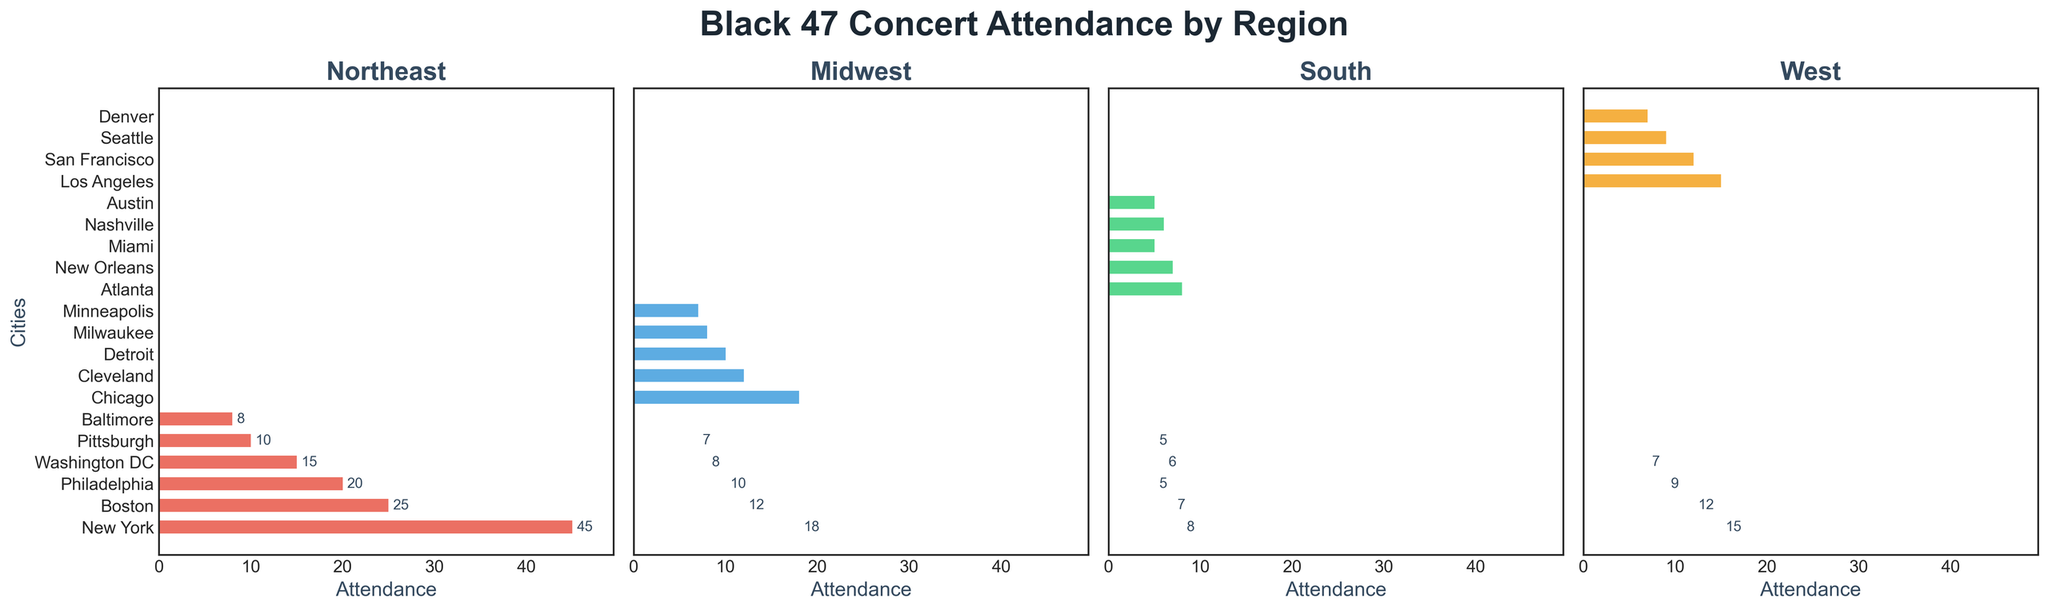How many cities in the Northeast region have concert attendance greater than 20? From the bar chart for the Northeast, count the cities with attendance bars exceeding the 20 mark, which are New York (45), Boston (25), and Philadelphia (20 but not exceeding 20). Only New York and Boston have attendance greater than 20.
Answer: 2 Which city in the Midwest has the highest concert attendance? In the Midwest subplot, the city with the highest bar is Chicago with an attendance of 18.
Answer: Chicago What is the total concert attendance for cities in the South region? Sum up the attendance values from the bars in the South subplot: Atlanta (8) + New Orleans (7) + Miami (5) + Nashville (6) + Austin (5) = 31
Answer: 31 Compare concert attendance between Los Angeles and Seattle in the West region. Which one had more attendees? In the West subplot, observe the lengths of the bars for Los Angeles and Seattle. Los Angeles has a bar at 15, while Seattle has a bar at 9. Los Angeles has more attendees.
Answer: Los Angeles What is the average concert attendance for cities in the Northeast region shown in the plot? Calculate the average by summing the attendance numbers in the Northeast region and dividing by the number of cities: (45+25+20+15+10+8) / 6 = 20.5
Answer: 20.5 Is concert attendance in Milwaukee greater than or equal to New Orleans? Compare the heights of the bars for Milwaukee (Midwest subplot, 8) and New Orleans (South subplot, 7). Milwaukee has a taller bar, so its attendance is greater.
Answer: Yes Identify the city with the lowest concert attendance in each region. Observe the shortest bar in each subplot: 
- Northeast: Baltimore (8) 
- Midwest: Minneapolis (7) 
- South: Austin and Miami (both 5) 
- West: Denver (7)
Answer: Baltimore, Minneapolis, Austin and Miami, Denver Add up the concert attendance for Midwest and West regions. What's the combined total? Sum the attendance for the Midwest (Chicago 18 + Cleveland 12 + Detroit 10 + Milwaukee 8 + Minneapolis 7 = 55) and the West (Los Angeles 15 + San Francisco 12 + Seattle 9 + Denver 7 = 43). Then, add these sums: 55 + 43 = 98
Answer: 98 